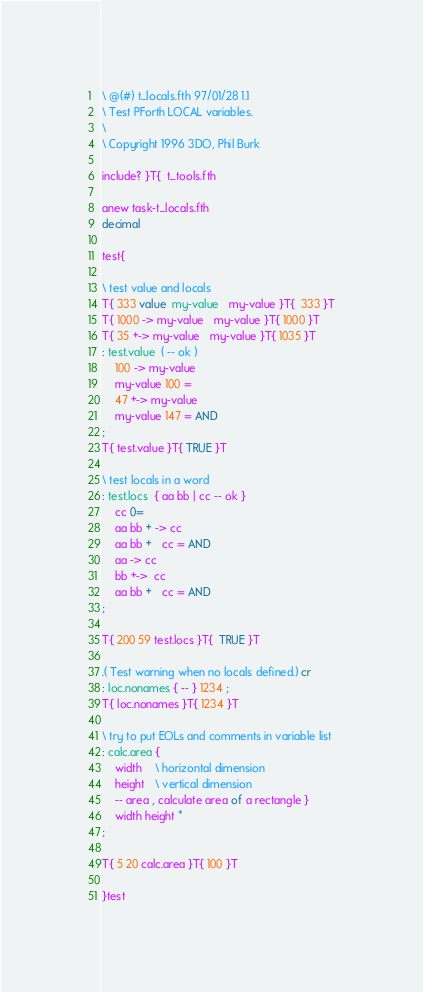<code> <loc_0><loc_0><loc_500><loc_500><_Forth_>\ @(#) t_locals.fth 97/01/28 1.1
\ Test PForth LOCAL variables.
\
\ Copyright 1996 3DO, Phil Burk

include? }T{  t_tools.fth

anew task-t_locals.fth
decimal

test{

\ test value and locals
T{ 333 value  my-value   my-value }T{  333 }T
T{ 1000 -> my-value   my-value }T{ 1000 }T
T{ 35 +-> my-value   my-value }T{ 1035 }T
: test.value  ( -- ok )
	100 -> my-value
	my-value 100 =
	47 +-> my-value
	my-value 147 = AND
;
T{ test.value }T{ TRUE }T

\ test locals in a word
: test.locs  { aa bb | cc -- ok }
	cc 0=
	aa bb + -> cc
	aa bb +   cc = AND
	aa -> cc
	bb +->  cc
	aa bb +   cc = AND
;

T{ 200 59 test.locs }T{  TRUE }T

.( Test warning when no locals defined.) cr
: loc.nonames { -- } 1234 ;
T{ loc.nonames }T{ 1234 }T

\ try to put EOLs and comments in variable list
: calc.area {
	width    \ horizontal dimension
	height   \ vertical dimension
	-- area , calculate area of a rectangle }
	width height *
;

T{ 5 20 calc.area }T{ 100 }T

}test

</code> 